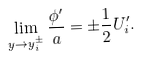Convert formula to latex. <formula><loc_0><loc_0><loc_500><loc_500>\lim _ { y \to y _ { i } ^ { \pm } } \frac { \phi ^ { \prime } } { a } = \pm \frac { 1 } { 2 } U ^ { \prime } _ { i } .</formula> 